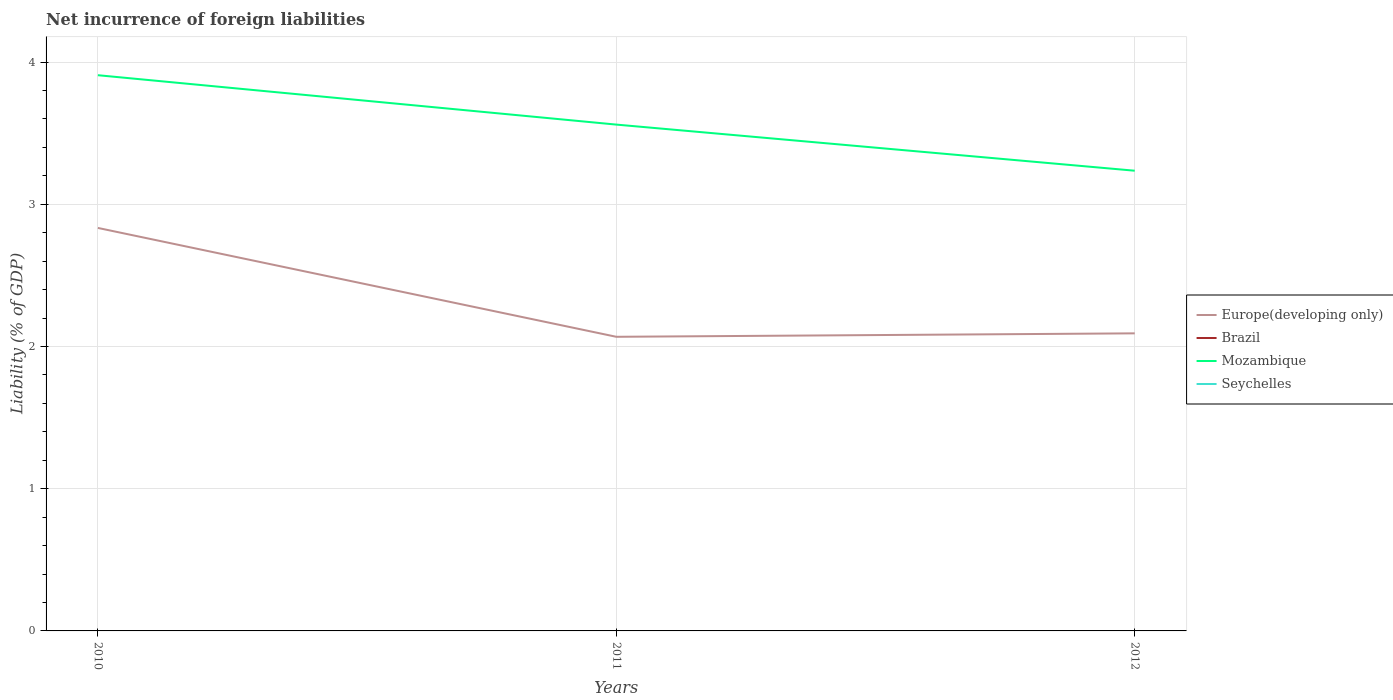Across all years, what is the maximum net incurrence of foreign liabilities in Europe(developing only)?
Offer a terse response. 2.07. What is the total net incurrence of foreign liabilities in Mozambique in the graph?
Offer a terse response. 0.67. What is the difference between the highest and the lowest net incurrence of foreign liabilities in Europe(developing only)?
Keep it short and to the point. 1. How many lines are there?
Provide a succinct answer. 2. How many years are there in the graph?
Give a very brief answer. 3. Are the values on the major ticks of Y-axis written in scientific E-notation?
Make the answer very short. No. Does the graph contain any zero values?
Ensure brevity in your answer.  Yes. Where does the legend appear in the graph?
Ensure brevity in your answer.  Center right. How are the legend labels stacked?
Make the answer very short. Vertical. What is the title of the graph?
Provide a succinct answer. Net incurrence of foreign liabilities. What is the label or title of the Y-axis?
Keep it short and to the point. Liability (% of GDP). What is the Liability (% of GDP) of Europe(developing only) in 2010?
Offer a terse response. 2.83. What is the Liability (% of GDP) in Mozambique in 2010?
Give a very brief answer. 3.91. What is the Liability (% of GDP) of Europe(developing only) in 2011?
Your answer should be compact. 2.07. What is the Liability (% of GDP) of Brazil in 2011?
Your answer should be compact. 0. What is the Liability (% of GDP) of Mozambique in 2011?
Provide a succinct answer. 3.56. What is the Liability (% of GDP) of Europe(developing only) in 2012?
Offer a very short reply. 2.09. What is the Liability (% of GDP) in Brazil in 2012?
Your response must be concise. 0. What is the Liability (% of GDP) of Mozambique in 2012?
Offer a very short reply. 3.24. Across all years, what is the maximum Liability (% of GDP) in Europe(developing only)?
Offer a very short reply. 2.83. Across all years, what is the maximum Liability (% of GDP) in Mozambique?
Your answer should be very brief. 3.91. Across all years, what is the minimum Liability (% of GDP) of Europe(developing only)?
Ensure brevity in your answer.  2.07. Across all years, what is the minimum Liability (% of GDP) of Mozambique?
Ensure brevity in your answer.  3.24. What is the total Liability (% of GDP) in Europe(developing only) in the graph?
Offer a terse response. 7. What is the total Liability (% of GDP) of Brazil in the graph?
Your response must be concise. 0. What is the total Liability (% of GDP) in Mozambique in the graph?
Make the answer very short. 10.7. What is the total Liability (% of GDP) in Seychelles in the graph?
Provide a succinct answer. 0. What is the difference between the Liability (% of GDP) in Europe(developing only) in 2010 and that in 2011?
Keep it short and to the point. 0.77. What is the difference between the Liability (% of GDP) in Mozambique in 2010 and that in 2011?
Offer a terse response. 0.35. What is the difference between the Liability (% of GDP) in Europe(developing only) in 2010 and that in 2012?
Give a very brief answer. 0.74. What is the difference between the Liability (% of GDP) in Mozambique in 2010 and that in 2012?
Ensure brevity in your answer.  0.67. What is the difference between the Liability (% of GDP) of Europe(developing only) in 2011 and that in 2012?
Offer a very short reply. -0.02. What is the difference between the Liability (% of GDP) in Mozambique in 2011 and that in 2012?
Keep it short and to the point. 0.32. What is the difference between the Liability (% of GDP) of Europe(developing only) in 2010 and the Liability (% of GDP) of Mozambique in 2011?
Give a very brief answer. -0.73. What is the difference between the Liability (% of GDP) in Europe(developing only) in 2010 and the Liability (% of GDP) in Mozambique in 2012?
Your answer should be compact. -0.4. What is the difference between the Liability (% of GDP) in Europe(developing only) in 2011 and the Liability (% of GDP) in Mozambique in 2012?
Provide a short and direct response. -1.17. What is the average Liability (% of GDP) in Europe(developing only) per year?
Offer a very short reply. 2.33. What is the average Liability (% of GDP) of Mozambique per year?
Your response must be concise. 3.57. What is the average Liability (% of GDP) of Seychelles per year?
Your answer should be compact. 0. In the year 2010, what is the difference between the Liability (% of GDP) of Europe(developing only) and Liability (% of GDP) of Mozambique?
Your response must be concise. -1.07. In the year 2011, what is the difference between the Liability (% of GDP) of Europe(developing only) and Liability (% of GDP) of Mozambique?
Your answer should be very brief. -1.49. In the year 2012, what is the difference between the Liability (% of GDP) of Europe(developing only) and Liability (% of GDP) of Mozambique?
Offer a very short reply. -1.14. What is the ratio of the Liability (% of GDP) in Europe(developing only) in 2010 to that in 2011?
Provide a succinct answer. 1.37. What is the ratio of the Liability (% of GDP) in Mozambique in 2010 to that in 2011?
Offer a terse response. 1.1. What is the ratio of the Liability (% of GDP) in Europe(developing only) in 2010 to that in 2012?
Keep it short and to the point. 1.35. What is the ratio of the Liability (% of GDP) of Mozambique in 2010 to that in 2012?
Your response must be concise. 1.21. What is the ratio of the Liability (% of GDP) of Europe(developing only) in 2011 to that in 2012?
Give a very brief answer. 0.99. What is the ratio of the Liability (% of GDP) in Mozambique in 2011 to that in 2012?
Keep it short and to the point. 1.1. What is the difference between the highest and the second highest Liability (% of GDP) in Europe(developing only)?
Provide a short and direct response. 0.74. What is the difference between the highest and the second highest Liability (% of GDP) of Mozambique?
Provide a succinct answer. 0.35. What is the difference between the highest and the lowest Liability (% of GDP) in Europe(developing only)?
Keep it short and to the point. 0.77. What is the difference between the highest and the lowest Liability (% of GDP) in Mozambique?
Offer a terse response. 0.67. 